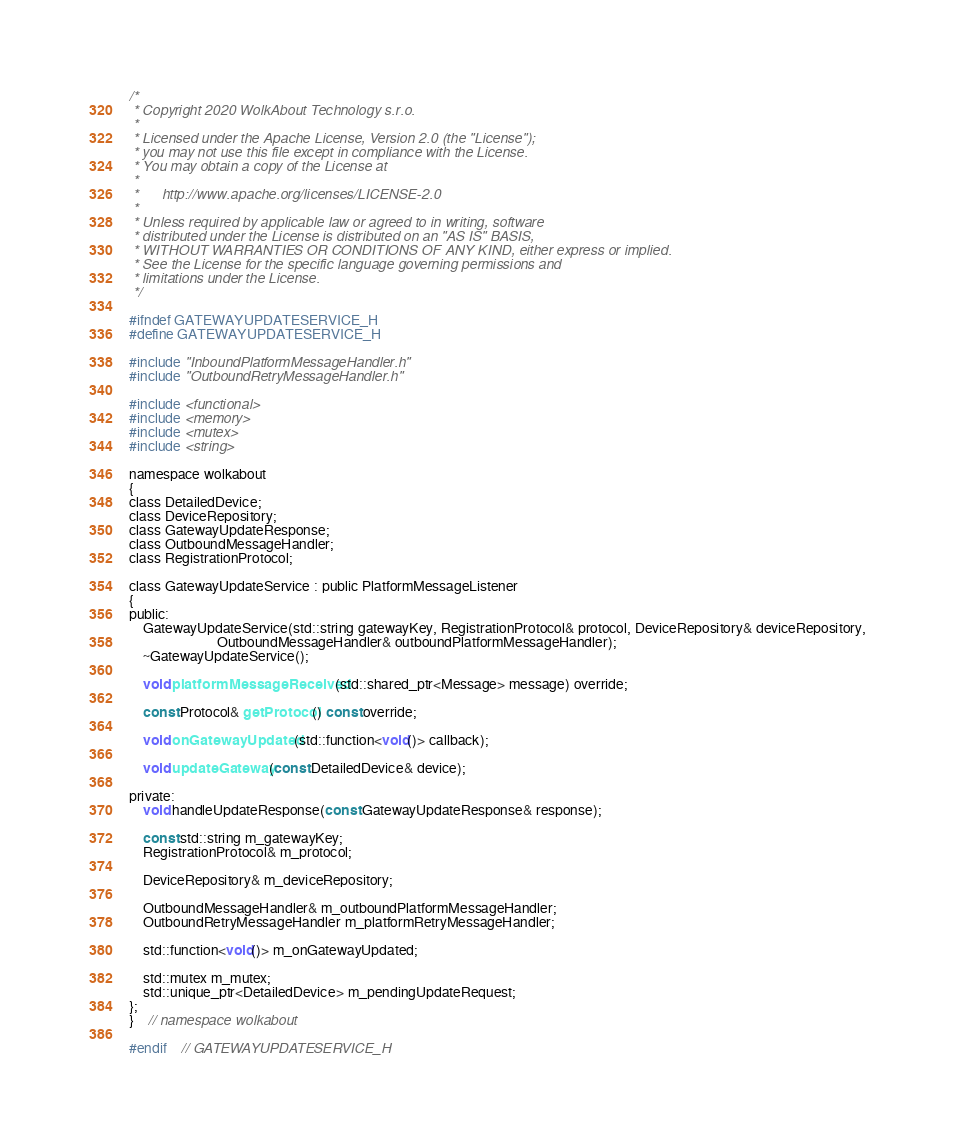Convert code to text. <code><loc_0><loc_0><loc_500><loc_500><_C_>/*
 * Copyright 2020 WolkAbout Technology s.r.o.
 *
 * Licensed under the Apache License, Version 2.0 (the "License");
 * you may not use this file except in compliance with the License.
 * You may obtain a copy of the License at
 *
 *      http://www.apache.org/licenses/LICENSE-2.0
 *
 * Unless required by applicable law or agreed to in writing, software
 * distributed under the License is distributed on an "AS IS" BASIS,
 * WITHOUT WARRANTIES OR CONDITIONS OF ANY KIND, either express or implied.
 * See the License for the specific language governing permissions and
 * limitations under the License.
 */

#ifndef GATEWAYUPDATESERVICE_H
#define GATEWAYUPDATESERVICE_H

#include "InboundPlatformMessageHandler.h"
#include "OutboundRetryMessageHandler.h"

#include <functional>
#include <memory>
#include <mutex>
#include <string>

namespace wolkabout
{
class DetailedDevice;
class DeviceRepository;
class GatewayUpdateResponse;
class OutboundMessageHandler;
class RegistrationProtocol;

class GatewayUpdateService : public PlatformMessageListener
{
public:
    GatewayUpdateService(std::string gatewayKey, RegistrationProtocol& protocol, DeviceRepository& deviceRepository,
                         OutboundMessageHandler& outboundPlatformMessageHandler);
    ~GatewayUpdateService();

    void platformMessageReceived(std::shared_ptr<Message> message) override;

    const Protocol& getProtocol() const override;

    void onGatewayUpdated(std::function<void()> callback);

    void updateGateway(const DetailedDevice& device);

private:
    void handleUpdateResponse(const GatewayUpdateResponse& response);

    const std::string m_gatewayKey;
    RegistrationProtocol& m_protocol;

    DeviceRepository& m_deviceRepository;

    OutboundMessageHandler& m_outboundPlatformMessageHandler;
    OutboundRetryMessageHandler m_platformRetryMessageHandler;

    std::function<void()> m_onGatewayUpdated;

    std::mutex m_mutex;
    std::unique_ptr<DetailedDevice> m_pendingUpdateRequest;
};
}    // namespace wolkabout

#endif    // GATEWAYUPDATESERVICE_H
</code> 